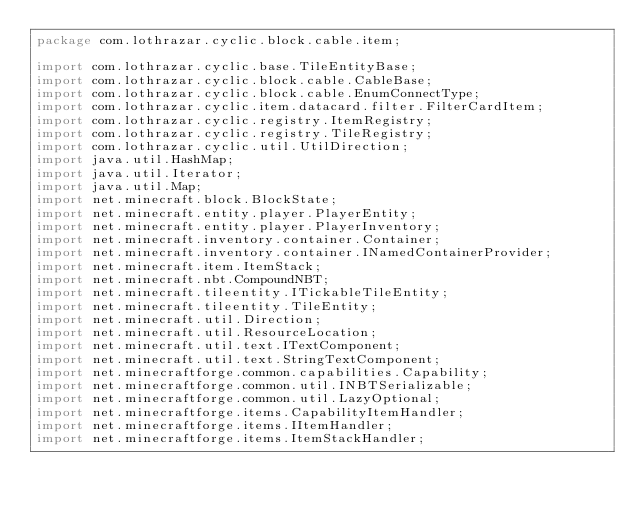Convert code to text. <code><loc_0><loc_0><loc_500><loc_500><_Java_>package com.lothrazar.cyclic.block.cable.item;

import com.lothrazar.cyclic.base.TileEntityBase;
import com.lothrazar.cyclic.block.cable.CableBase;
import com.lothrazar.cyclic.block.cable.EnumConnectType;
import com.lothrazar.cyclic.item.datacard.filter.FilterCardItem;
import com.lothrazar.cyclic.registry.ItemRegistry;
import com.lothrazar.cyclic.registry.TileRegistry;
import com.lothrazar.cyclic.util.UtilDirection;
import java.util.HashMap;
import java.util.Iterator;
import java.util.Map;
import net.minecraft.block.BlockState;
import net.minecraft.entity.player.PlayerEntity;
import net.minecraft.entity.player.PlayerInventory;
import net.minecraft.inventory.container.Container;
import net.minecraft.inventory.container.INamedContainerProvider;
import net.minecraft.item.ItemStack;
import net.minecraft.nbt.CompoundNBT;
import net.minecraft.tileentity.ITickableTileEntity;
import net.minecraft.tileentity.TileEntity;
import net.minecraft.util.Direction;
import net.minecraft.util.ResourceLocation;
import net.minecraft.util.text.ITextComponent;
import net.minecraft.util.text.StringTextComponent;
import net.minecraftforge.common.capabilities.Capability;
import net.minecraftforge.common.util.INBTSerializable;
import net.minecraftforge.common.util.LazyOptional;
import net.minecraftforge.items.CapabilityItemHandler;
import net.minecraftforge.items.IItemHandler;
import net.minecraftforge.items.ItemStackHandler;
</code> 